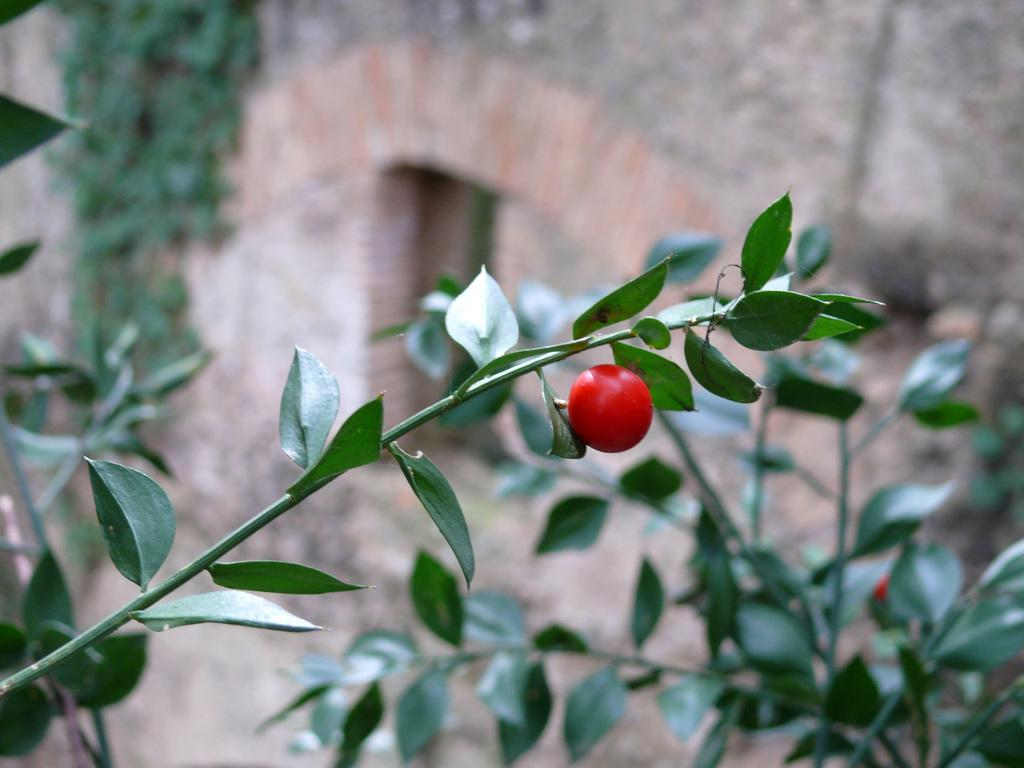What type of plant is the main subject in the image? There is a small tomato plant in the image. Are there any other plants visible in the image? Yes, there are more plants visible behind the tomato plant. What activity is the writer engaged in while holding the tomato plant in the image? There is no writer or activity involving a tomato plant depicted in the image. 